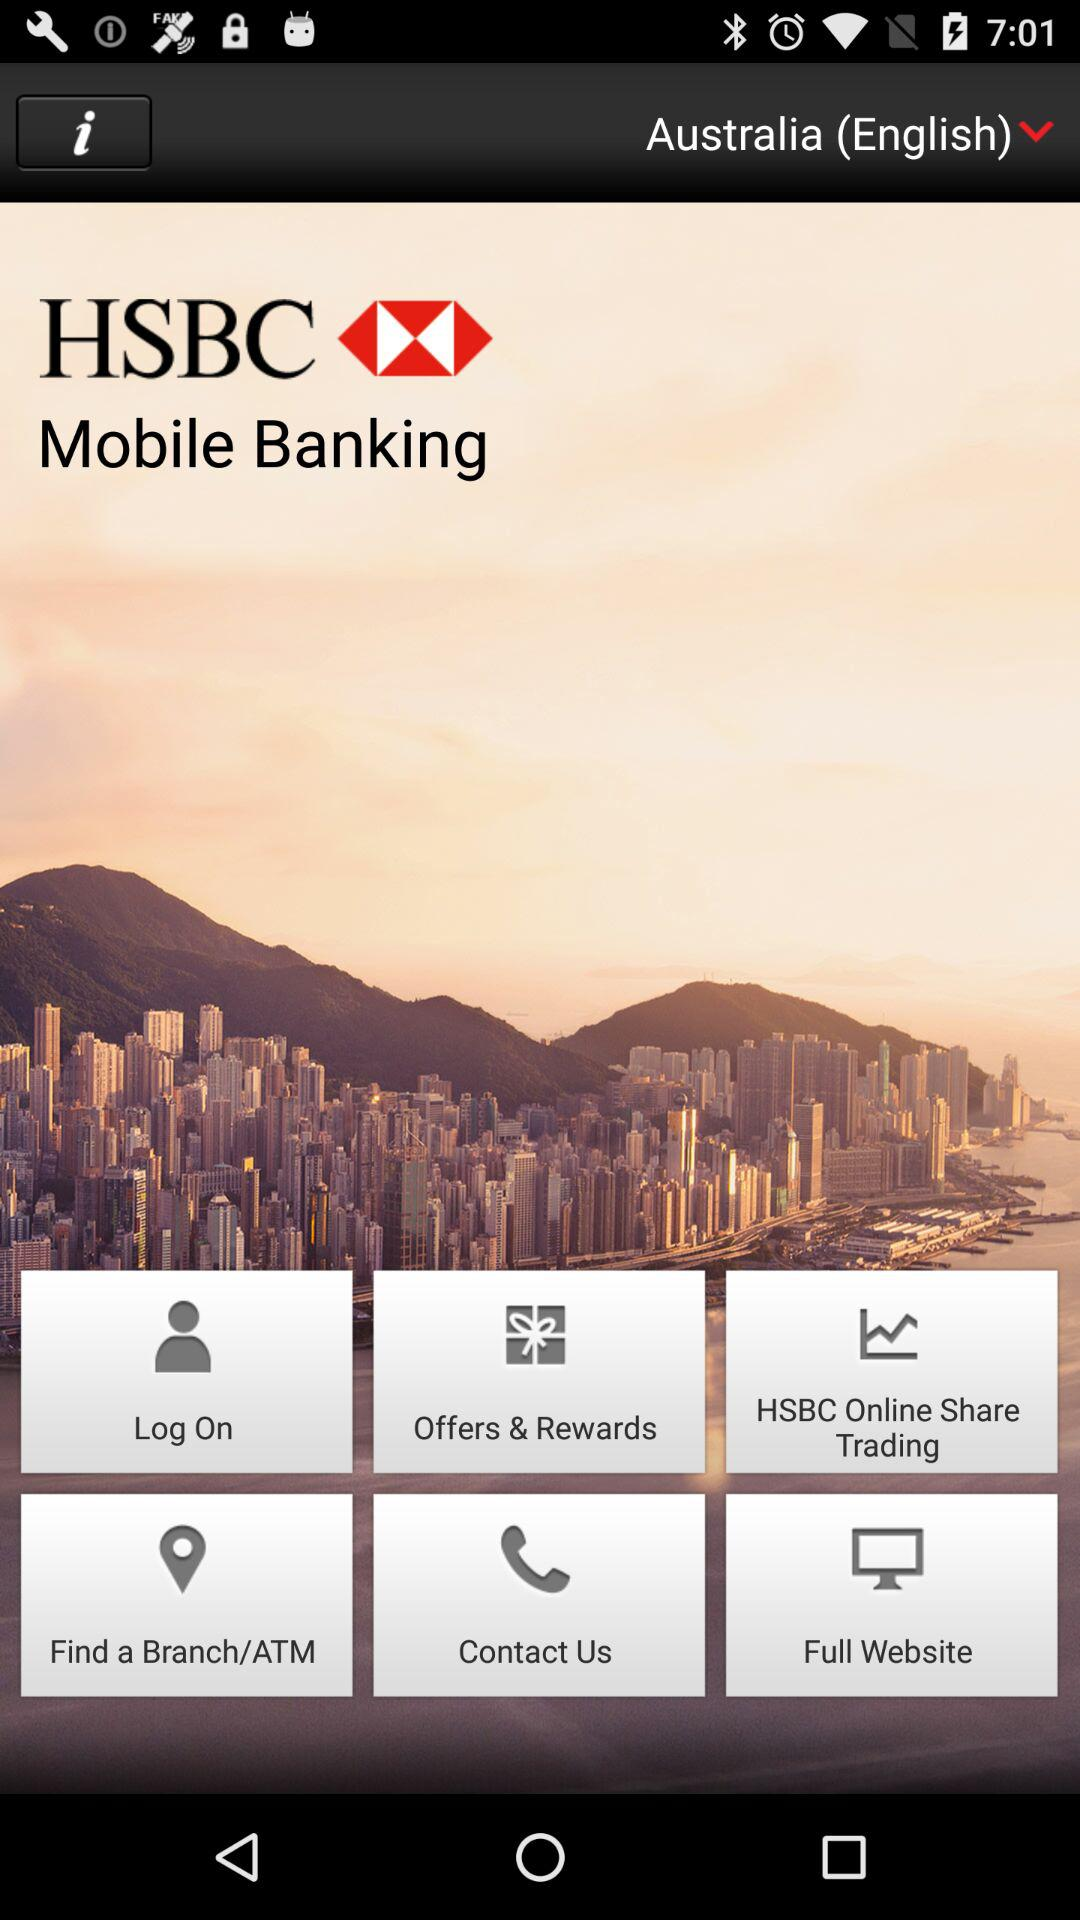What is the selected language? The selected language is "Australia (English)". 